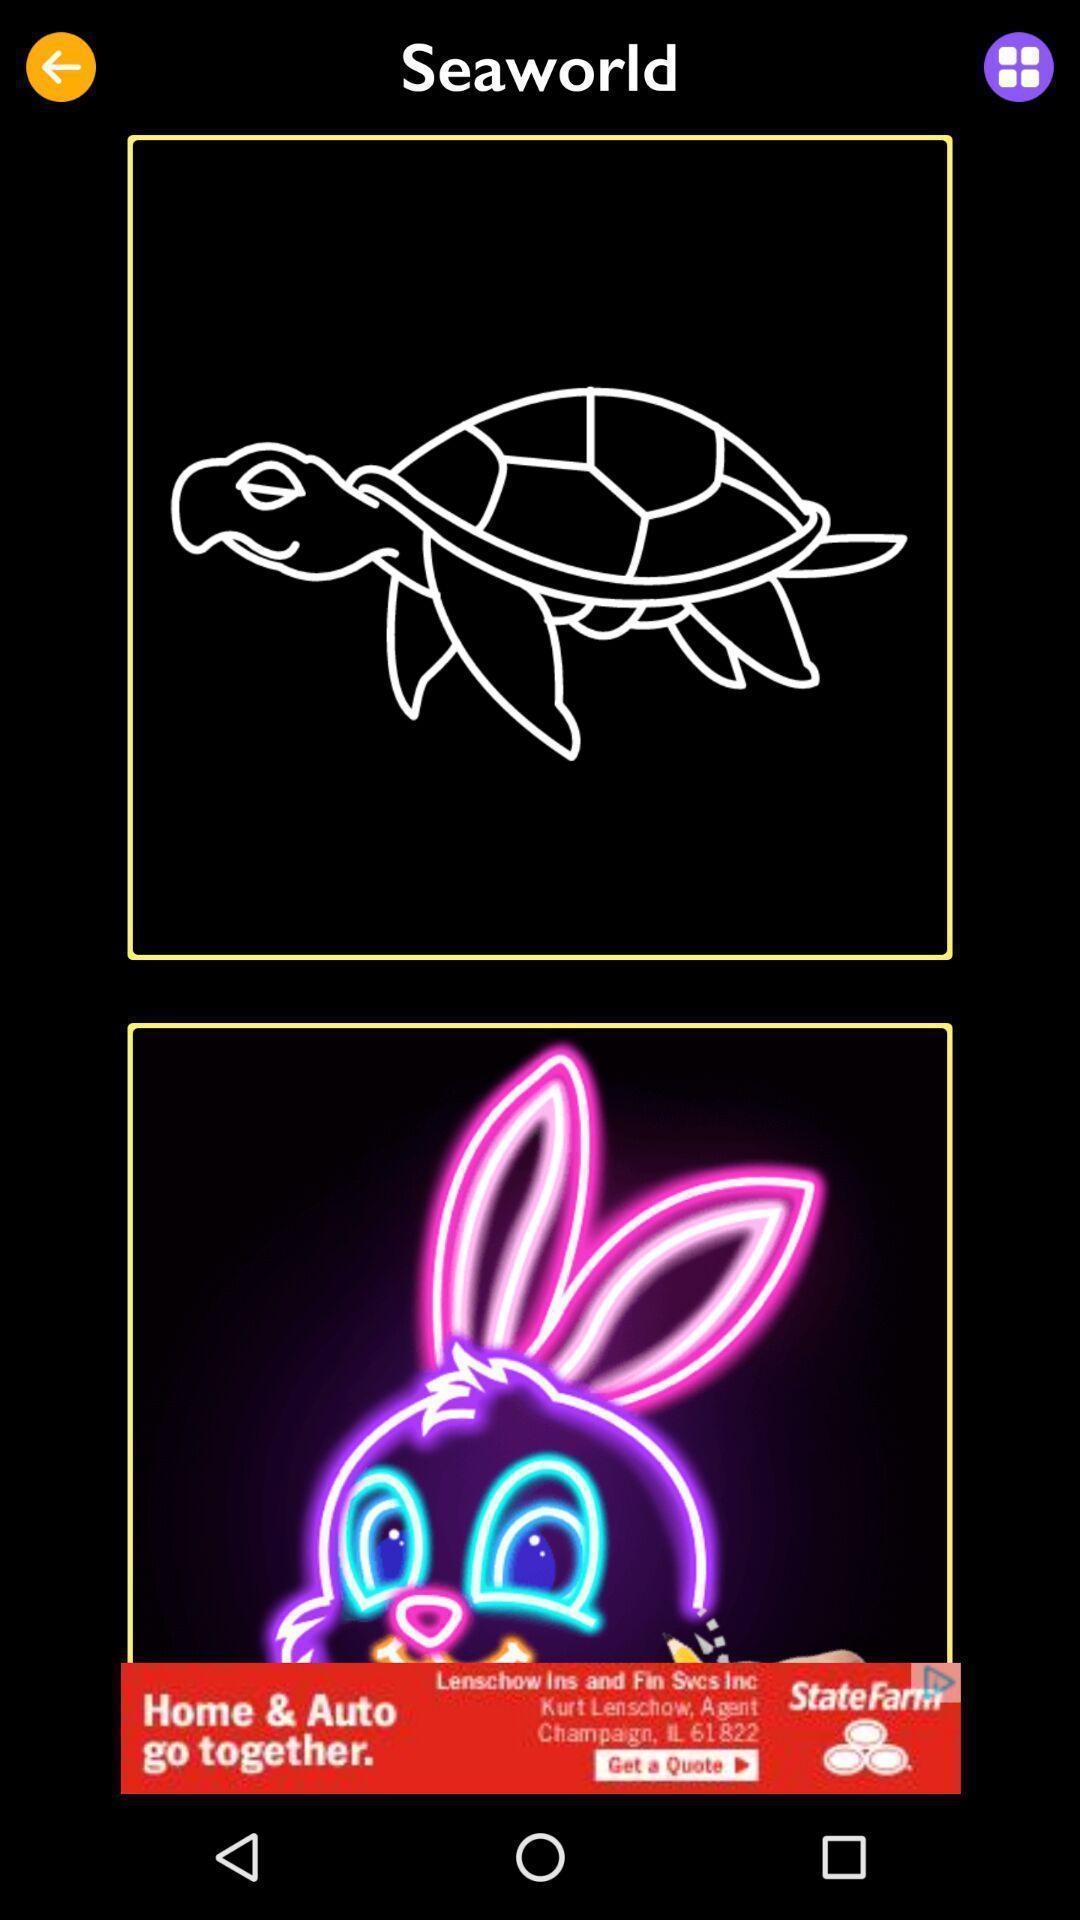Tell me what you see in this picture. Screen showing page of an drawing application. 